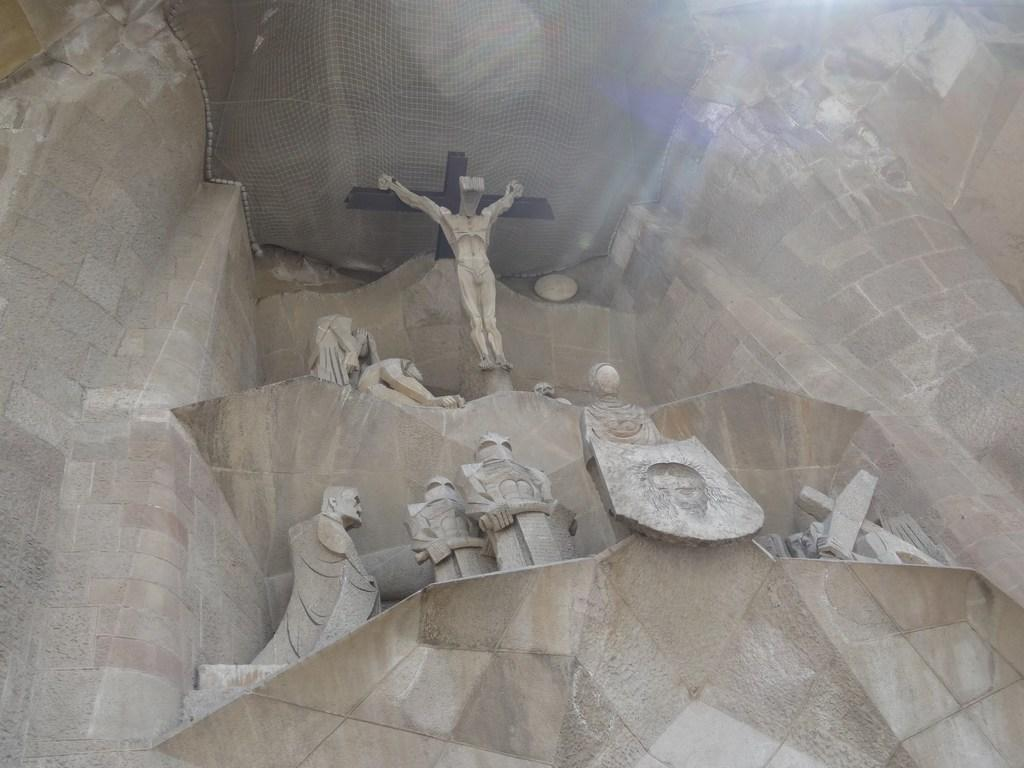What can be seen in the middle of the image? There are statues in the middle of the image. What is located at the top of the image? There is a net at the top of the image. What type of structure is present in the middle of the image? There is a wall in the middle of the image. What type of music can be heard coming from the statues in the image? There is no indication in the image that the statues are producing music, so it's not possible to determine what, if any, music might be heard. 